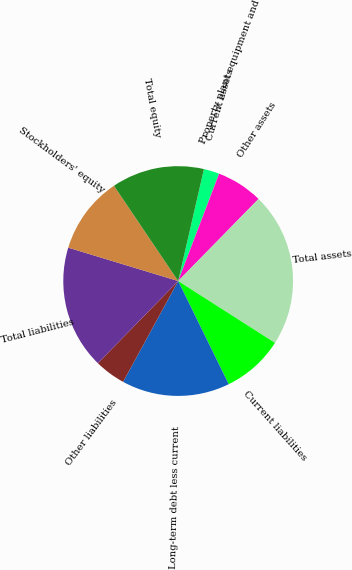Convert chart to OTSL. <chart><loc_0><loc_0><loc_500><loc_500><pie_chart><fcel>Current assets<fcel>Property plant equipment and<fcel>Other assets<fcel>Total assets<fcel>Current liabilities<fcel>Long-term debt less current<fcel>Other liabilities<fcel>Total liabilities<fcel>Stockholders' equity<fcel>Total equity<nl><fcel>2.19%<fcel>0.01%<fcel>6.53%<fcel>21.72%<fcel>8.7%<fcel>15.21%<fcel>4.36%<fcel>17.38%<fcel>10.87%<fcel>13.04%<nl></chart> 